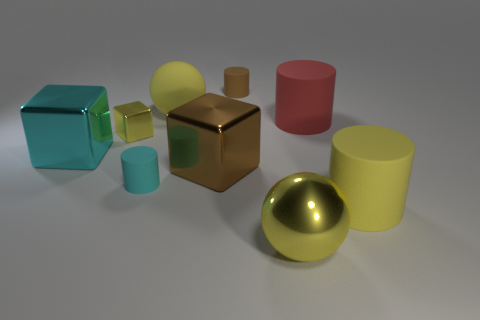Is the number of yellow metallic spheres that are on the right side of the large yellow cylinder greater than the number of big red things? No, the number of yellow metallic spheres on the right side of the large yellow cylinder, which is one, is not greater than the number of big red things, since there is one large red cylinder present, making them equal in number. 